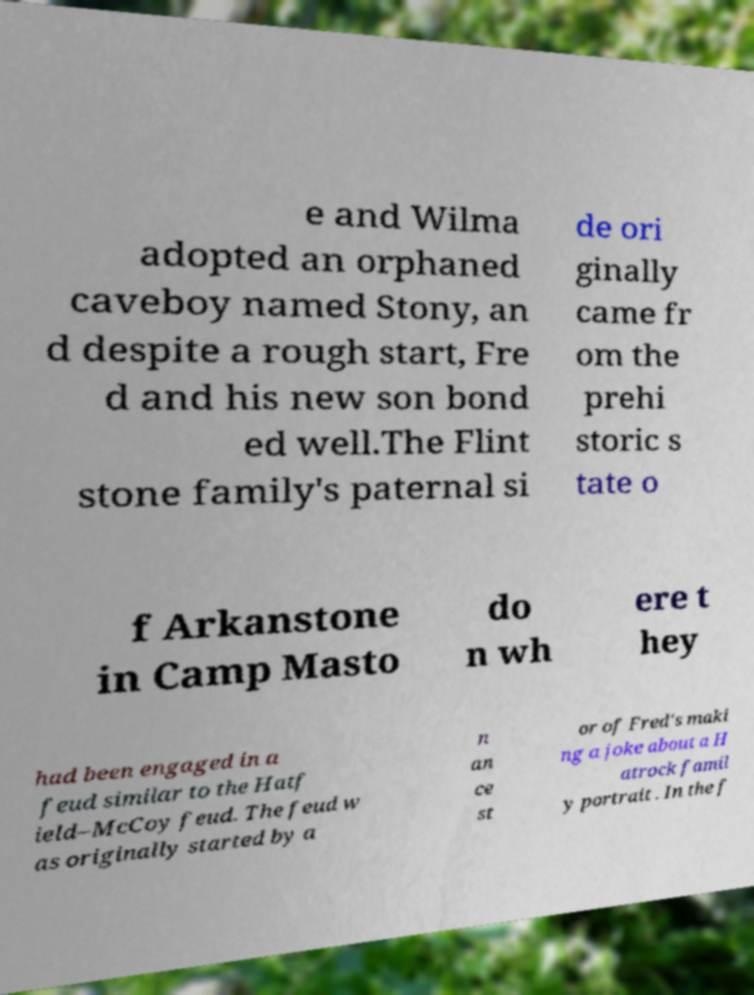Can you accurately transcribe the text from the provided image for me? e and Wilma adopted an orphaned caveboy named Stony, an d despite a rough start, Fre d and his new son bond ed well.The Flint stone family's paternal si de ori ginally came fr om the prehi storic s tate o f Arkanstone in Camp Masto do n wh ere t hey had been engaged in a feud similar to the Hatf ield–McCoy feud. The feud w as originally started by a n an ce st or of Fred's maki ng a joke about a H atrock famil y portrait . In the f 